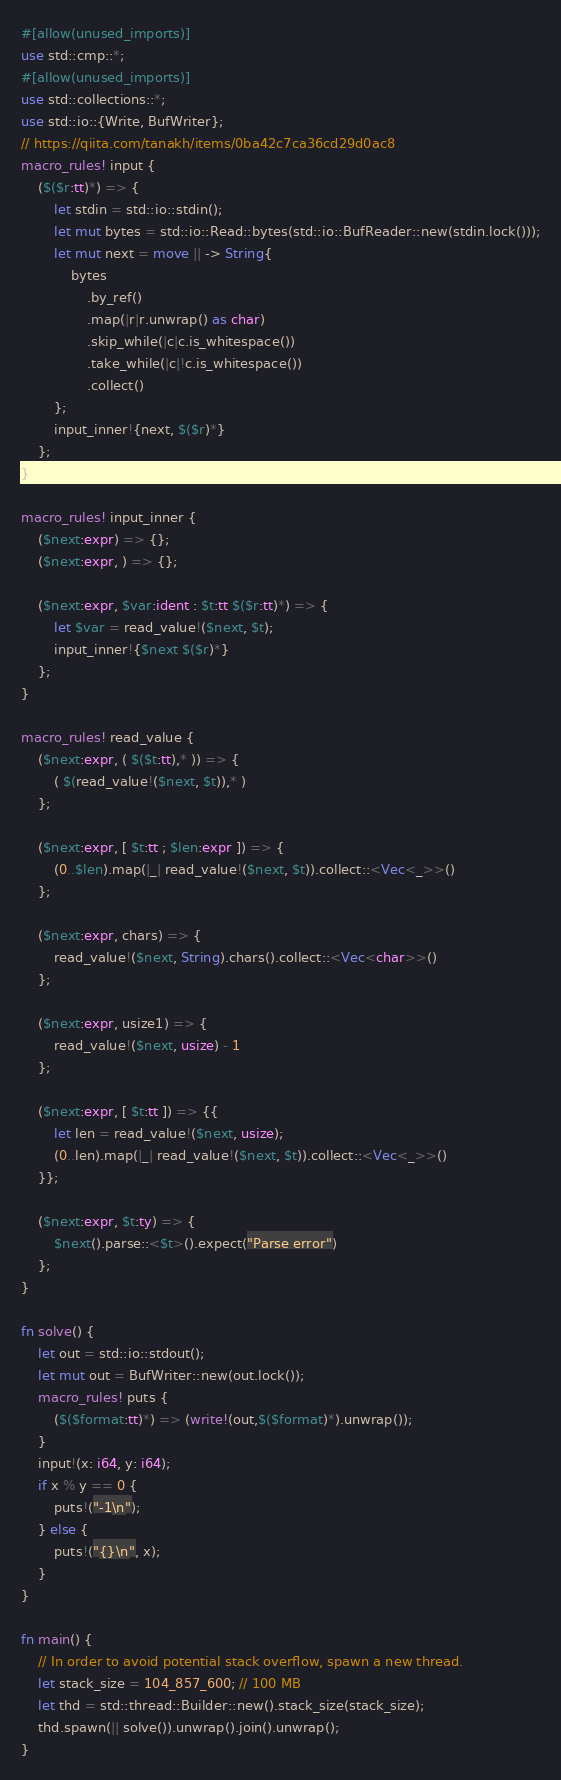<code> <loc_0><loc_0><loc_500><loc_500><_Rust_>#[allow(unused_imports)]
use std::cmp::*;
#[allow(unused_imports)]
use std::collections::*;
use std::io::{Write, BufWriter};
// https://qiita.com/tanakh/items/0ba42c7ca36cd29d0ac8
macro_rules! input {
    ($($r:tt)*) => {
        let stdin = std::io::stdin();
        let mut bytes = std::io::Read::bytes(std::io::BufReader::new(stdin.lock()));
        let mut next = move || -> String{
            bytes
                .by_ref()
                .map(|r|r.unwrap() as char)
                .skip_while(|c|c.is_whitespace())
                .take_while(|c|!c.is_whitespace())
                .collect()
        };
        input_inner!{next, $($r)*}
    };
}

macro_rules! input_inner {
    ($next:expr) => {};
    ($next:expr, ) => {};

    ($next:expr, $var:ident : $t:tt $($r:tt)*) => {
        let $var = read_value!($next, $t);
        input_inner!{$next $($r)*}
    };
}

macro_rules! read_value {
    ($next:expr, ( $($t:tt),* )) => {
        ( $(read_value!($next, $t)),* )
    };

    ($next:expr, [ $t:tt ; $len:expr ]) => {
        (0..$len).map(|_| read_value!($next, $t)).collect::<Vec<_>>()
    };

    ($next:expr, chars) => {
        read_value!($next, String).chars().collect::<Vec<char>>()
    };

    ($next:expr, usize1) => {
        read_value!($next, usize) - 1
    };

    ($next:expr, [ $t:tt ]) => {{
        let len = read_value!($next, usize);
        (0..len).map(|_| read_value!($next, $t)).collect::<Vec<_>>()
    }};

    ($next:expr, $t:ty) => {
        $next().parse::<$t>().expect("Parse error")
    };
}

fn solve() {
    let out = std::io::stdout();
    let mut out = BufWriter::new(out.lock());
    macro_rules! puts {
        ($($format:tt)*) => (write!(out,$($format)*).unwrap());
    }
    input!(x: i64, y: i64);
    if x % y == 0 {
        puts!("-1\n");
    } else {
        puts!("{}\n", x);
    }
}

fn main() {
    // In order to avoid potential stack overflow, spawn a new thread.
    let stack_size = 104_857_600; // 100 MB
    let thd = std::thread::Builder::new().stack_size(stack_size);
    thd.spawn(|| solve()).unwrap().join().unwrap();
}
</code> 